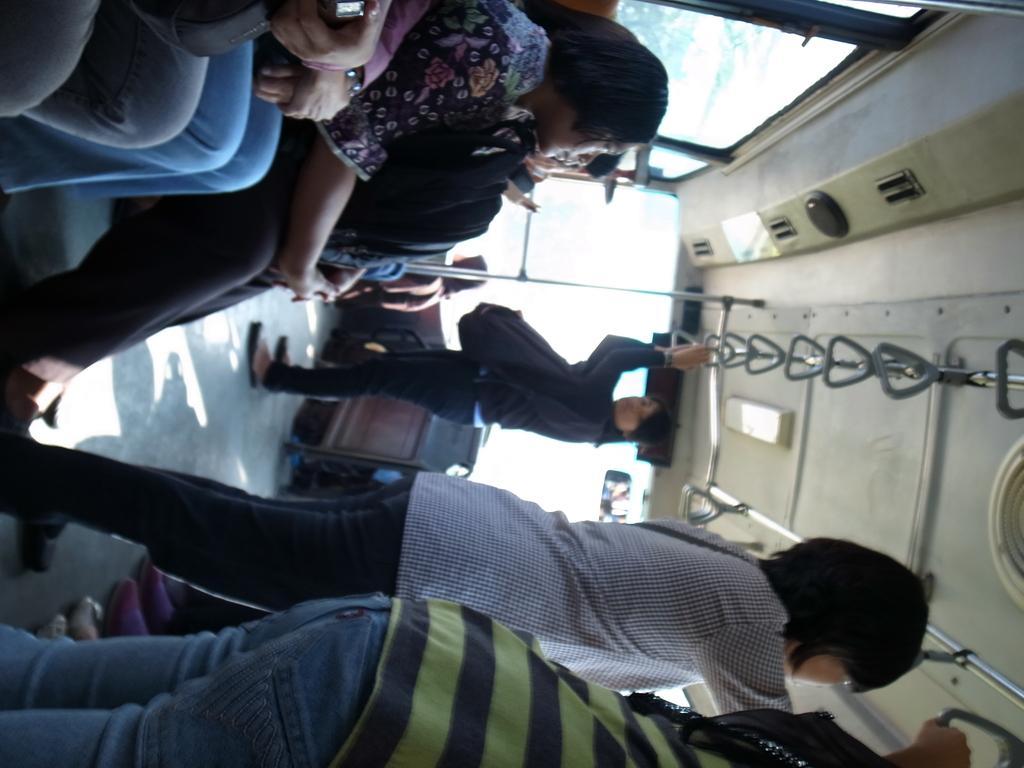Can you describe this image briefly? In this picture I can see a group of people are sitting at the top. In the middle few persons are standing and holding the roof handles, it looks like an inside part of a vehicle. At the top there are glass windows. 